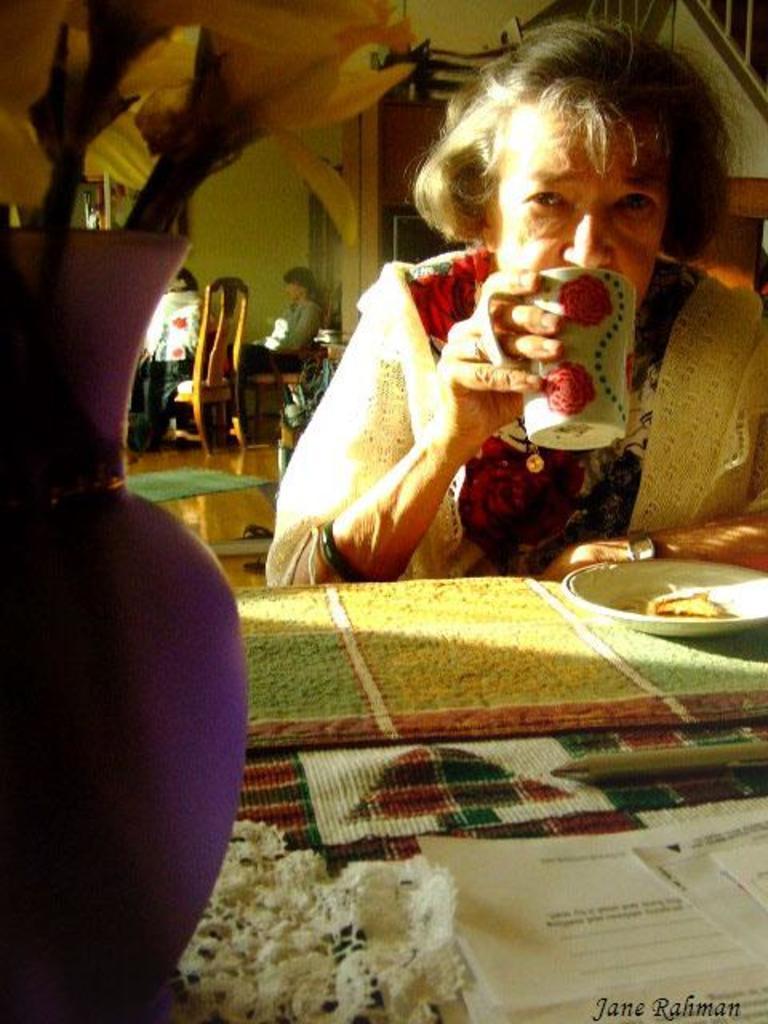Can you describe this image briefly? A woman is drinking in a cup. On the table there is a flower vase,plate and papers. In the background there is a wall and few people sitting on the chair. 